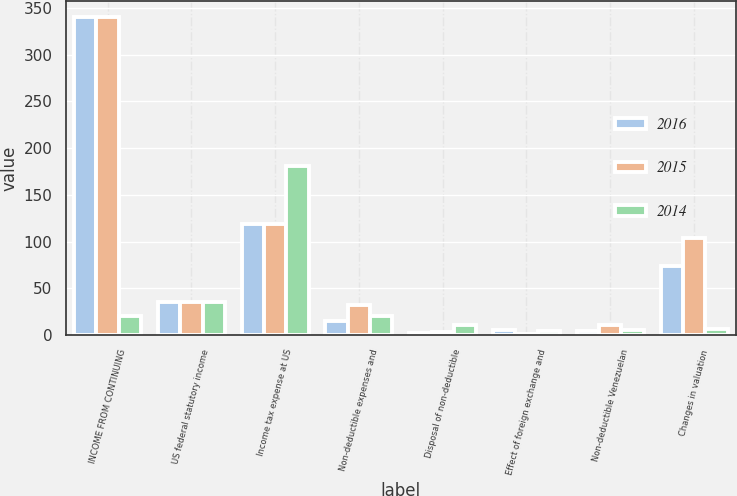Convert chart to OTSL. <chart><loc_0><loc_0><loc_500><loc_500><stacked_bar_chart><ecel><fcel>INCOME FROM CONTINUING<fcel>US federal statutory income<fcel>Income tax expense at US<fcel>Non-deductible expenses and<fcel>Disposal of non-deductible<fcel>Effect of foreign exchange and<fcel>Non-deductible Venezuelan<fcel>Changes in valuation<nl><fcel>2016<fcel>340<fcel>35<fcel>119<fcel>15<fcel>2<fcel>6<fcel>4<fcel>74<nl><fcel>2015<fcel>340<fcel>35<fcel>119<fcel>32<fcel>3<fcel>1<fcel>11<fcel>104<nl><fcel>2014<fcel>21<fcel>35<fcel>181<fcel>21<fcel>11<fcel>4<fcel>5<fcel>7<nl></chart> 